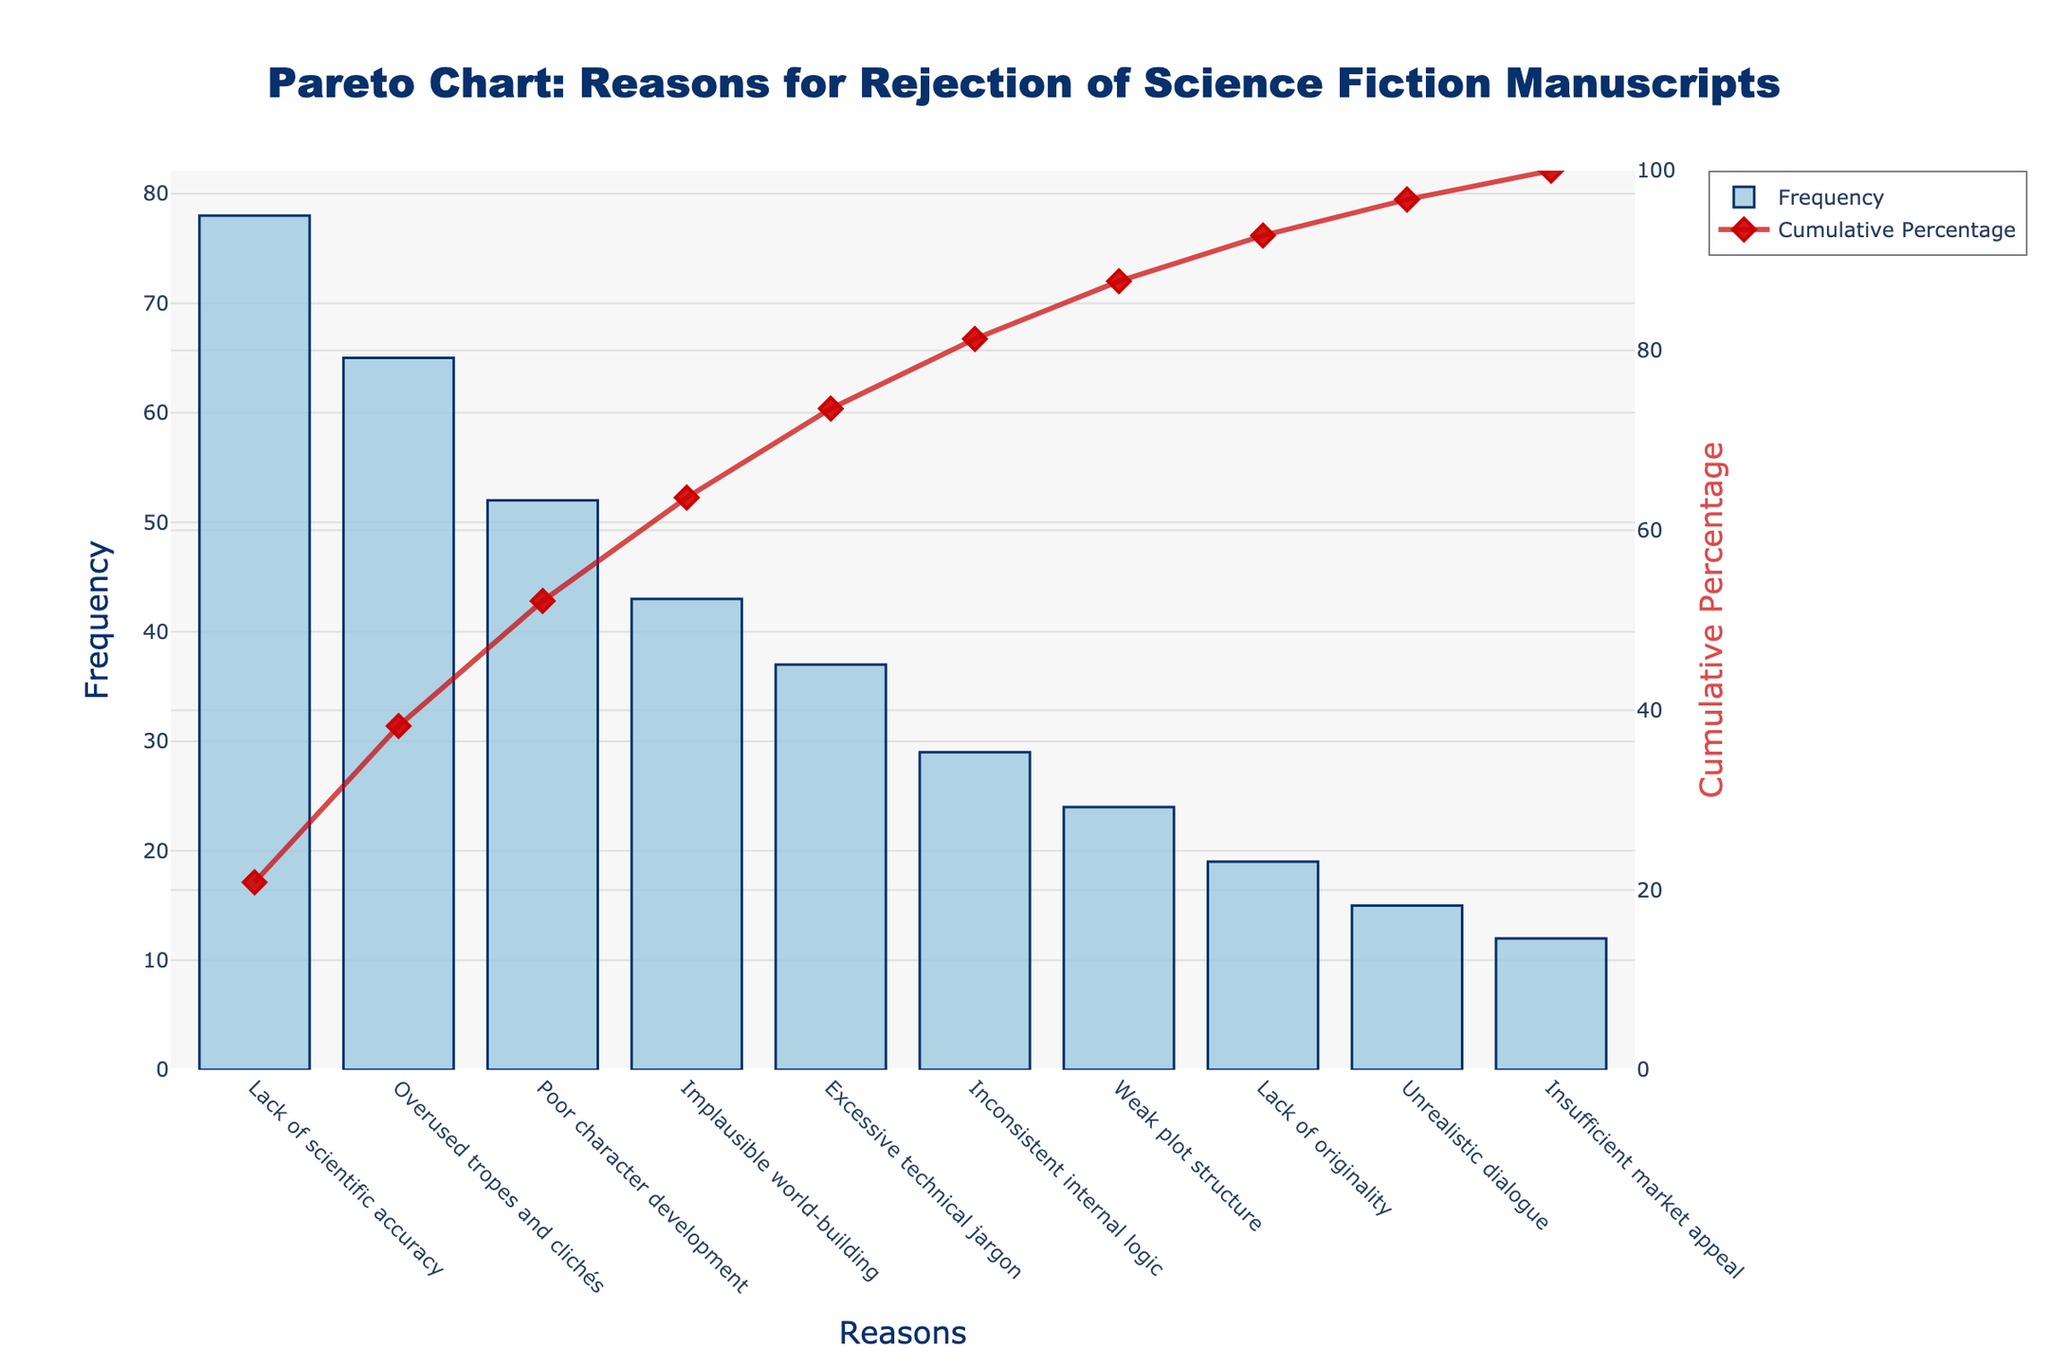What is the most frequent reason for the rejection of science fiction manuscripts? Look at the bar with the highest value in the bar chart.
Answer: Lack of scientific accuracy Which reason comes last on the chart when sorted by frequency? Find the last bar on the x-axis.
Answer: Insufficient market appeal What is the cumulative percentage after the first three reasons? Add the cumulative percentages shown by the line chart for the first three reasons: Lack of scientific accuracy, Overused tropes and clichés, and Poor character development.
Answer: 52.58 + 28.84 + 45.45 = 80.87% Which reason has a frequency of 24? Locate the bar with the height equal to 24 on the y-axis.
Answer: Weak plot structure What is the combined frequency of "Excessive technical jargon" and "Unrealistic dialogue"? Add the frequencies of "Excessive technical jargon" and "Unrealistic dialogue".
Answer: 37 + 15 = 52 Which reason has a lower frequency: "Poor character development" or "Implausible world-building"? Compare the heights of the bars representing "Poor character development" and "Implausible world-building".
Answer: Implausible world-building At what frequency value does the cumulative percentage hit approximately 90%? Identify the position on the line chart where the cumulative percentage nears 90%.
Answer: Between Inconsistent internal logic and Weak plot structure How many reasons contribute to reaching 50% of the cumulative percentage? Count the number of reasons that cumulatively add up to or surpass 50% on the line chart.
Answer: 2 If you combined the frequencies of "Inconsistent internal logic" and "Weak plot structure", would the cumulative percentage surpass 90%? Add the frequencies of "Inconsistent internal logic" (29) and "Weak plot structure" (24) and see if their cumulative percentage surpasses 90%.
Answer: Yes, 92.82% 